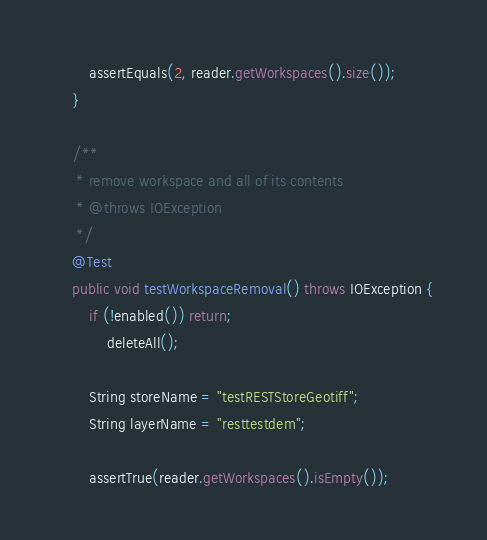Convert code to text. <code><loc_0><loc_0><loc_500><loc_500><_Java_>        assertEquals(2, reader.getWorkspaces().size());
    }
    
    /**
     * remove workspace and all of its contents
     * @throws IOException
     */
    @Test
    public void testWorkspaceRemoval() throws IOException {
        if (!enabled()) return;
        	deleteAll();

        String storeName = "testRESTStoreGeotiff";
        String layerName = "resttestdem";

        assertTrue(reader.getWorkspaces().isEmpty());</code> 